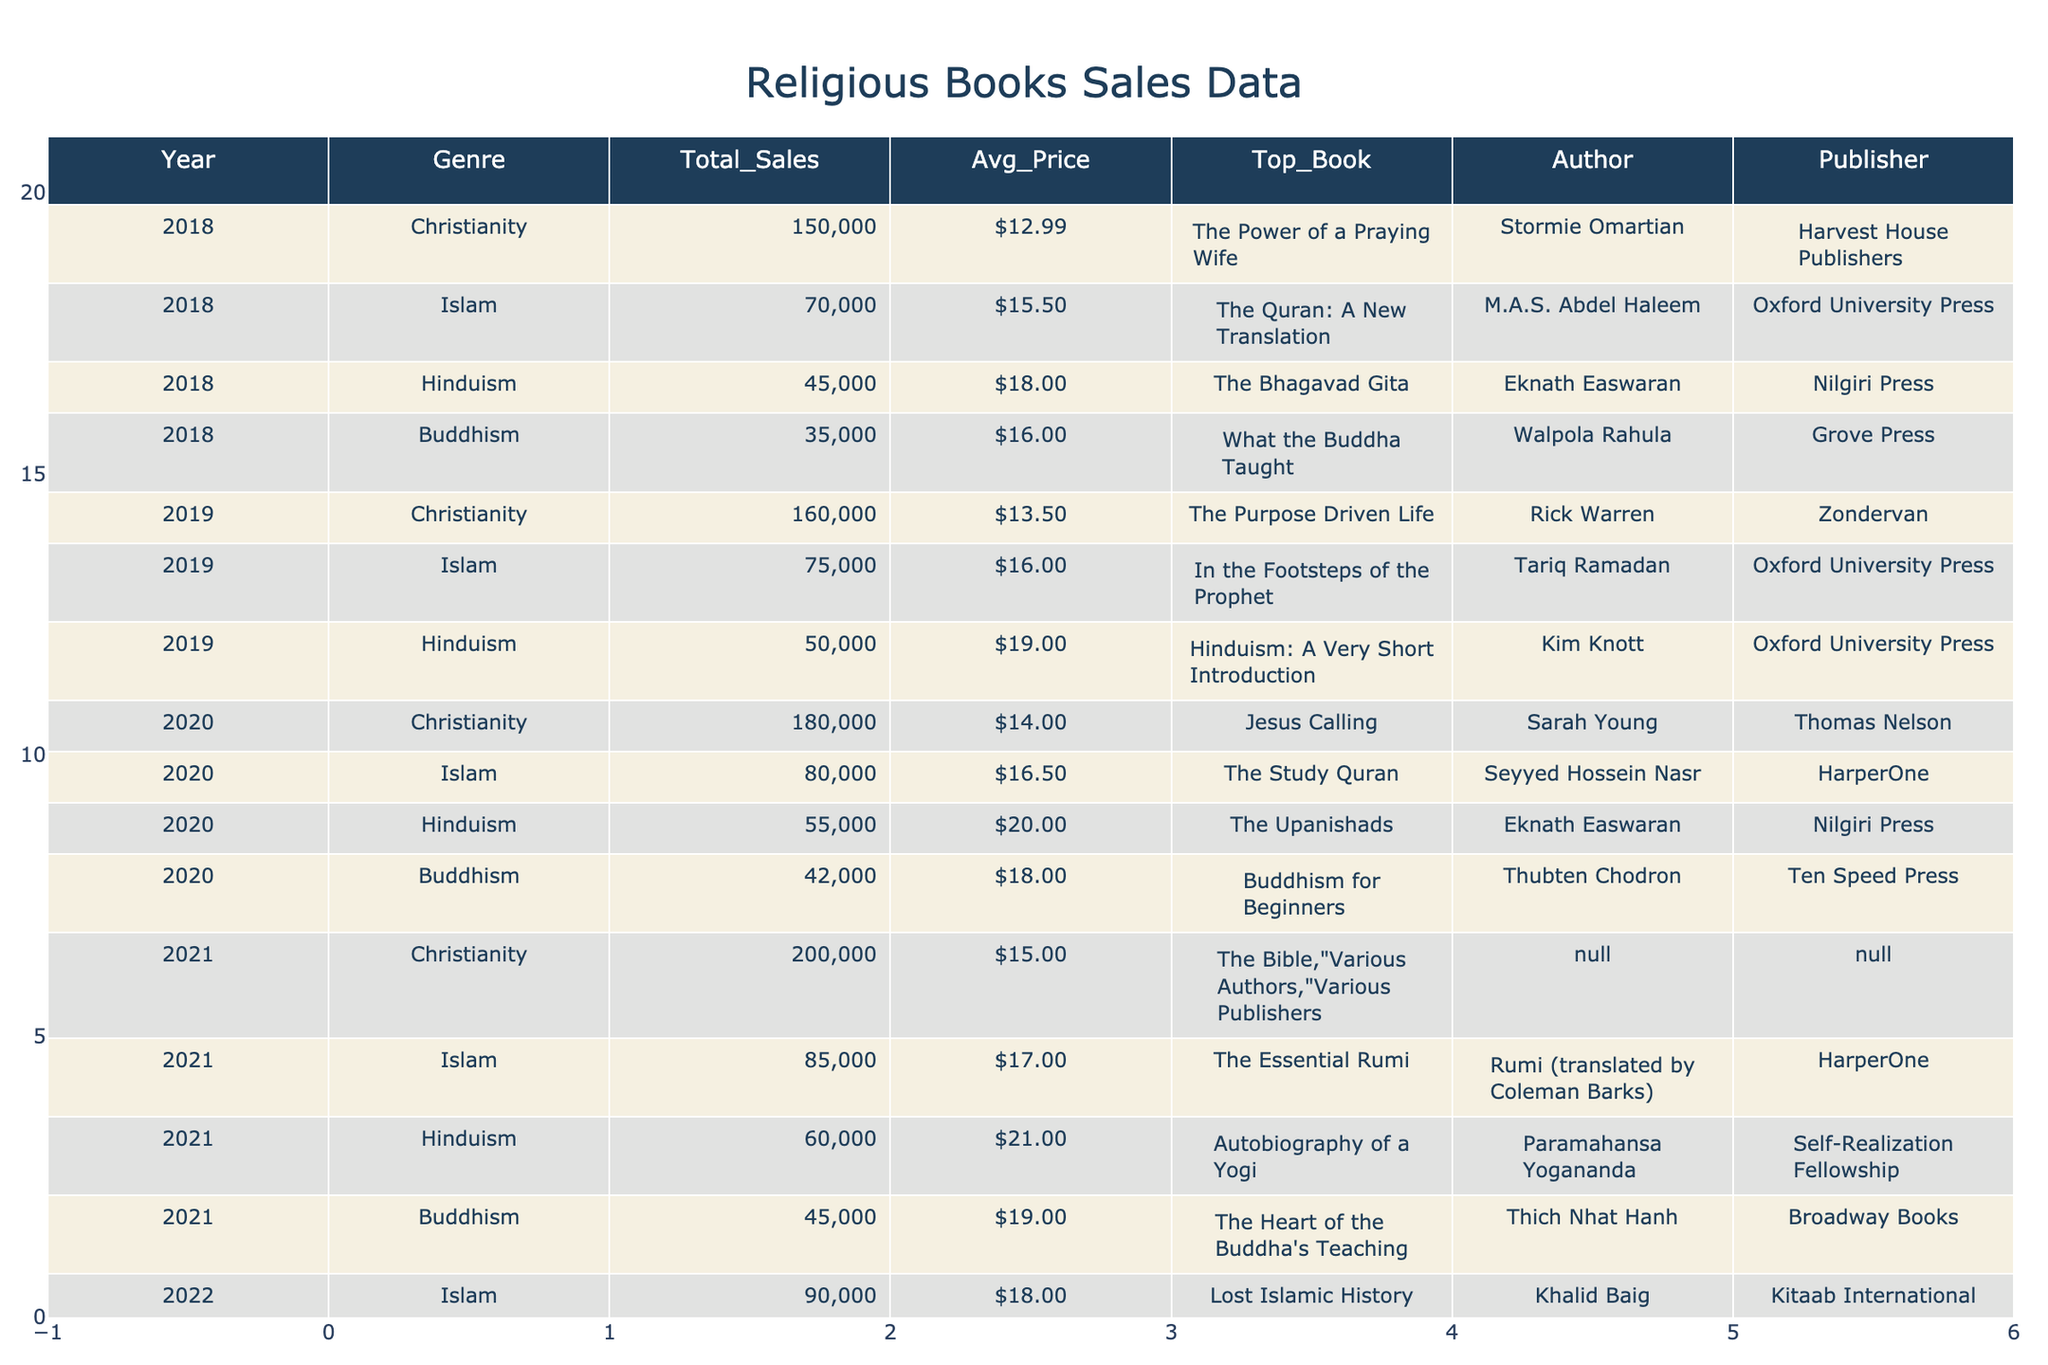What was the total sales for Buddhism in 2022? Looking at the table, the row for Buddhism in 2022 indicates a total sales figure of 48,000.
Answer: 48,000 Which genre had the highest average price in 2021? By checking the average prices for each genre in 2021, we find Christianity at $15, Islam at $17, Hinduism at $21, and Buddhism at $19. The highest is Hinduism at $21.
Answer: Hinduism What is the difference in total sales between Christianity in 2021 and in 2023? Christianity's total sales are 200,000 in 2021 and 240,000 in 2023. The difference is 240,000 - 200,000 = 40,000.
Answer: 40,000 Did sales for Hinduism increase every year from 2018 to 2023? Checking the total sales year by year for Hinduism, we see 45,000 in 2018, 50,000 in 2019, 55,000 in 2020, 60,000 in 2021, 65,000 in 2022, and 70,000 in 2023. All values are increasing.
Answer: Yes What is the average total sales for Islam from 2018 to 2023? To find the average, we add the total sales for Islam over the years: 70,000 (2018) + 75,000 (2019) + 80,000 (2020) + 85,000 (2021) + 90,000 (2022) + 95,000 (2023) = 495,000. The average is 495,000 / 6 = 82,500.
Answer: 82,500 Which publisher has the top-selling book in Christianity for 2023? In 2023, the top selling book in Christianity is "The 5 Love Languages" by Gary Chapman, published by Northfield Publishing.
Answer: Northfield Publishing If we compare the total sales of all genres in 2020, which genre had the lowest sales? The total sales for each genre in 2020 are: Christianity 180,000, Islam 80,000, Hinduism 55,000, and Buddhism 42,000. The lowest sales is by Buddhism at 42,000.
Answer: Buddhism What is the trend in total sales for Christianity from 2018 to 2023? Reviewing the total sales figures for Christianity: 150,000 in 2018, 160,000 in 2019, 180,000 in 2020, 200,000 in 2021, 240,000 in 2023. We see a consistent increase each year.
Answer: Increasing Which year showed the greatest average book price for Hinduism? Analyzing the average prices for Hinduism: 18.00 in 2018, 19.00 in 2019, 20.00 in 2020, 21.00 in 2021, 22.00 in 2022, and 23.00 in 2023, the highest average price is 23.00 in 2023.
Answer: 23.00 How much more did "The Bible" (2021) earn compared to "The Quran: A New Translation" (2018) in terms of total sales? Total sales for "The Bible" in 2021 was 200,000 and for "The Quran: A New Translation" in 2018 was 70,000. The earnings difference is 200,000 - 70,000 = 130,000.
Answer: 130,000 